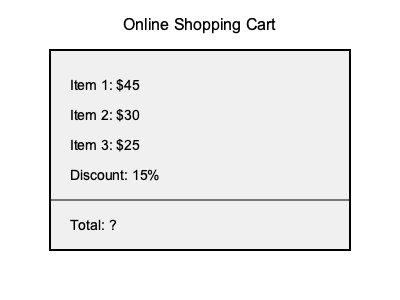Looking at your online shopping cart, you have three items with prices $45, $30, and $25. There's a 15% discount applied to the total. What is the final cost of your purchase? Let's calculate the total cost step-by-step:

1. Add up the prices of all items:
   $45 + $30 + $25 = $100$

2. Calculate the discount amount:
   15% of $100 = $0.15 \times 100 = $15$

3. Subtract the discount from the total:
   $100 - $15 = $85$

Therefore, the final cost of your purchase after applying the 15% discount is $85.
Answer: $85 